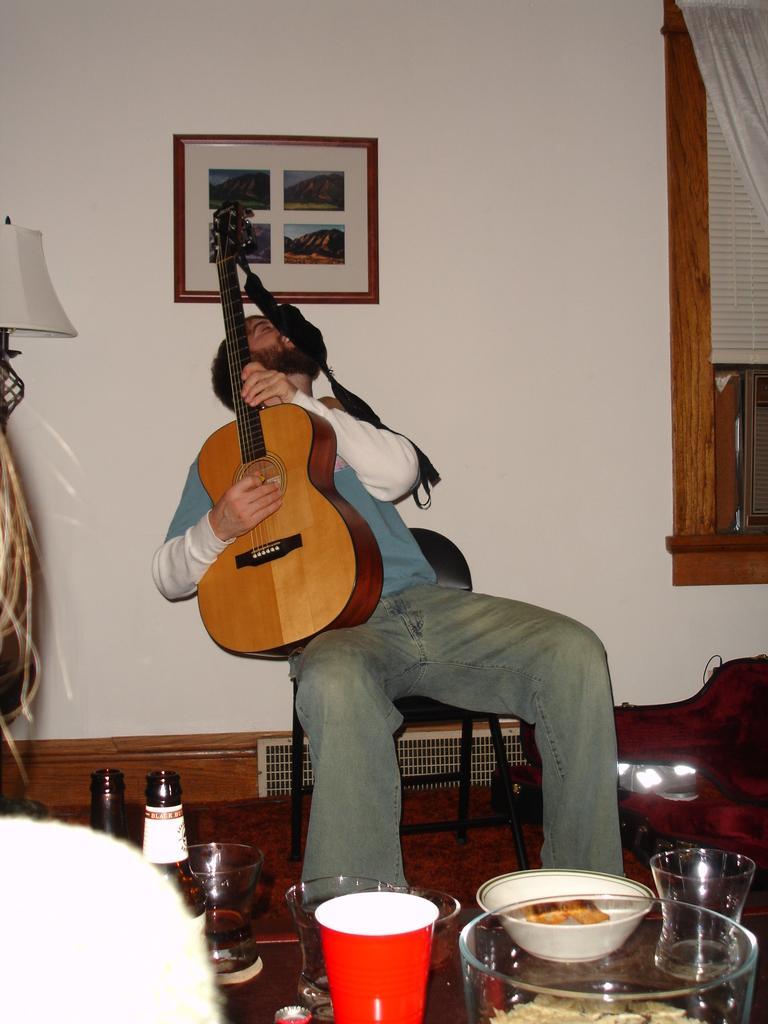How would you summarize this image in a sentence or two? In this picture in side of the room. He is sitting in a chair. He is holding guitar. His playing guitar. We can see in the background there is a photo frames,walls,curtains,window,glass,bottles and something food items. 